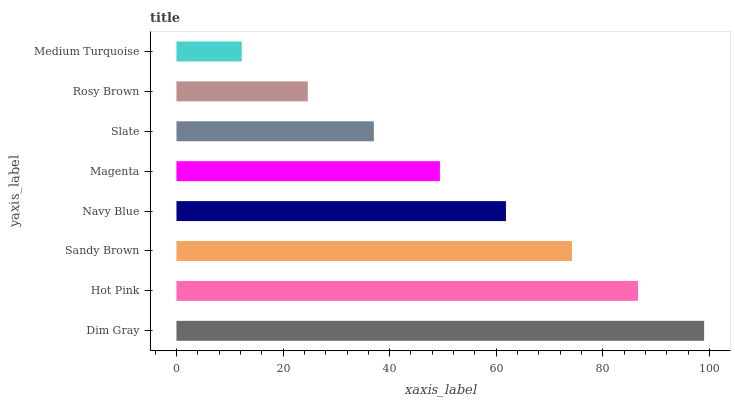Is Medium Turquoise the minimum?
Answer yes or no. Yes. Is Dim Gray the maximum?
Answer yes or no. Yes. Is Hot Pink the minimum?
Answer yes or no. No. Is Hot Pink the maximum?
Answer yes or no. No. Is Dim Gray greater than Hot Pink?
Answer yes or no. Yes. Is Hot Pink less than Dim Gray?
Answer yes or no. Yes. Is Hot Pink greater than Dim Gray?
Answer yes or no. No. Is Dim Gray less than Hot Pink?
Answer yes or no. No. Is Navy Blue the high median?
Answer yes or no. Yes. Is Magenta the low median?
Answer yes or no. Yes. Is Sandy Brown the high median?
Answer yes or no. No. Is Rosy Brown the low median?
Answer yes or no. No. 